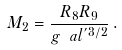<formula> <loc_0><loc_0><loc_500><loc_500>M _ { 2 } = \frac { R _ { 8 } R _ { 9 } } { g \ a l ^ { ^ { \prime } 3 / 2 } } \, .</formula> 